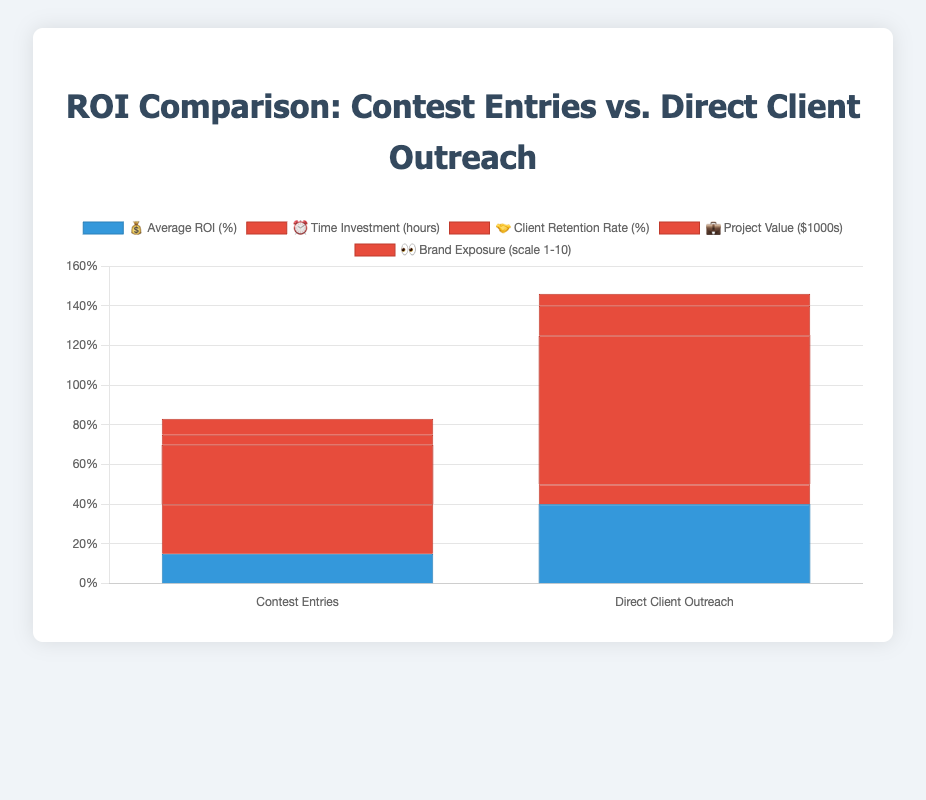What's the average ROI for Direct Client Outreach? Look at the "💰 Average ROI (%)" series in the chart and find the value for "Direct Client Outreach," which is 40%.
Answer: 40% Which approach has a higher Client Retention Rate? Compare the values of "🤝 Client Retention Rate (%)" for both categories. Direct Client Outreach has 75%, which is higher than Contest Entries' 30%.
Answer: Direct Client Outreach What's the total Project Value for both approaches? Sum the values of "💼 Project Value ($1000s)" for both Contest Entries and Direct Client Outreach. Contest Entries is 5 and Direct Client Outreach is 15, so 5 + 15 = 20.
Answer: 20 How much more time does Contest Entries require compared to Direct Client Outreach? Subtract the "⏰ Time Investment (hours)" for Direct Client Outreach (10) from Contest Entries (25). 25 - 10 = 15.
Answer: 15 Which has the higher Brand Exposure, and by how much? Compare the "👀 Brand Exposure (scale 1-10)" values. Contest Entries is 8 and Direct Client Outreach is 6, so the difference is 8 - 6 = 2.
Answer: Contest Entries by 2 What's the overall better approach based on the metrics shown? Direct Client Outreach has better values for Average ROI, Client Retention Rate, Time Investment, and Project Value. Contest Entries is better only in Brand Exposure. Majority metrics favor Direct Client Outreach.
Answer: Direct Client Outreach Is the Client Retention Rate of Direct Client Outreach more than double that of Contest Entries? Compare whether 75% (Direct Client Outreach) is more than double 30% (Contest Entries). 30% * 2 = 60%, and 75% > 60%.
Answer: Yes What's the ratio of Average ROI between Direct Client Outreach and Contest Entries? Divide the Average ROI for Direct Client Outreach by that for Contest Entries. 40 / 15 = 2.67.
Answer: 2.67 Does Contest Entries yield higher overall Brand Exposure? Compare the "👀 Brand Exposure" values for Contest Entries (8) and Direct Client Outreach (6). 8 is higher than 6.
Answer: Yes 